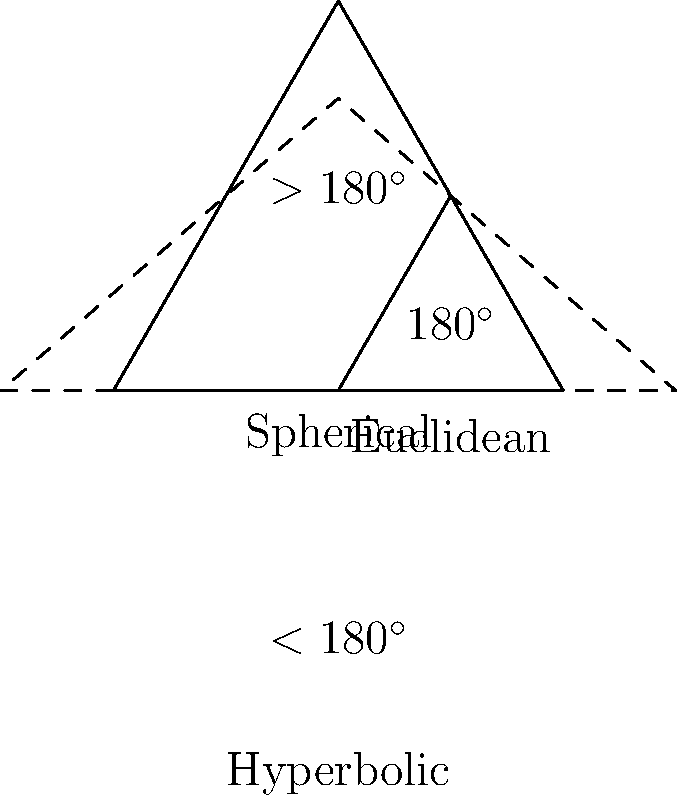As a University of Delaware alumni considering moving back to Pike Creek to start a family, you might appreciate the diverse applications of non-Euclidean geometry in modern technology. Compare the sum of interior angles in triangles across Euclidean, spherical, and hyperbolic geometries. Which geometry would be most suitable for GPS navigation in the Pike Creek area, and why? Let's analyze the sum of interior angles in triangles for each geometry:

1. Euclidean geometry:
   - Sum of interior angles = $180^\circ$
   - Represented by the middle triangle in the diagram
   - Applies to flat surfaces

2. Spherical geometry:
   - Sum of interior angles > $180^\circ$
   - Represented by the largest triangle in the diagram
   - Applies to curved surfaces with positive curvature (like a globe)

3. Hyperbolic geometry:
   - Sum of interior angles < $180^\circ$
   - Represented by the dashed triangle in the diagram
   - Applies to curved surfaces with negative curvature

For GPS navigation in Pike Creek:
- The Earth's surface is approximately spherical
- Over small areas like Pike Creek, the curvature is minimal
- Euclidean geometry provides a good approximation for local navigation
- Spherical geometry becomes important for long-distance calculations

Therefore, while spherical geometry is technically more accurate for GPS on a global scale, Euclidean geometry would be most suitable for local navigation in Pike Creek due to its simplicity and sufficient accuracy for small areas.
Answer: Euclidean geometry, as it provides sufficient accuracy for local navigation in Pike Creek while being computationally simpler than spherical geometry. 